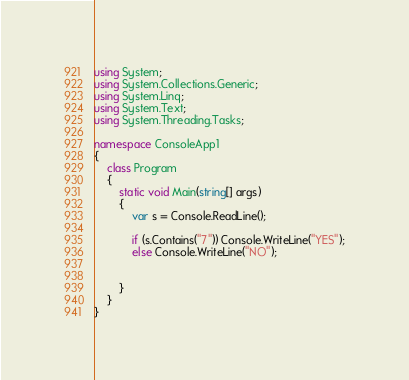<code> <loc_0><loc_0><loc_500><loc_500><_C#_>using System;
using System.Collections.Generic;
using System.Linq;
using System.Text;
using System.Threading.Tasks;

namespace ConsoleApp1
{
    class Program
    {
        static void Main(string[] args)
        {
            var s = Console.ReadLine();

            if (s.Contains("7")) Console.WriteLine("YES");
            else Console.WriteLine("NO");


        }
    }
}
</code> 